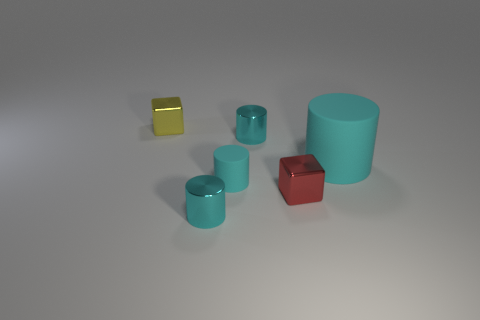Do the cyan metal object that is in front of the large matte object and the large thing that is right of the yellow metal cube have the same shape?
Keep it short and to the point. Yes. Does the yellow shiny block have the same size as the cyan rubber thing on the right side of the red shiny object?
Offer a terse response. No. What material is the yellow thing?
Give a very brief answer. Metal. There is a thing that is both on the left side of the small cyan matte cylinder and in front of the tiny yellow shiny block; what material is it?
Keep it short and to the point. Metal. There is a tiny thing in front of the shiny cube on the right side of the tiny yellow object; what is its material?
Offer a very short reply. Metal. How many other rubber things are the same shape as the large cyan thing?
Provide a succinct answer. 1. What number of things are either objects in front of the big rubber thing or objects that are in front of the big cyan matte thing?
Ensure brevity in your answer.  3. Is there a tiny cylinder that is to the right of the small cylinder in front of the tiny cyan rubber cylinder?
Make the answer very short. Yes. There is a red object that is the same size as the yellow shiny block; what is its shape?
Provide a short and direct response. Cube. What number of things are either small cylinders behind the red block or small yellow cubes?
Offer a very short reply. 3. 